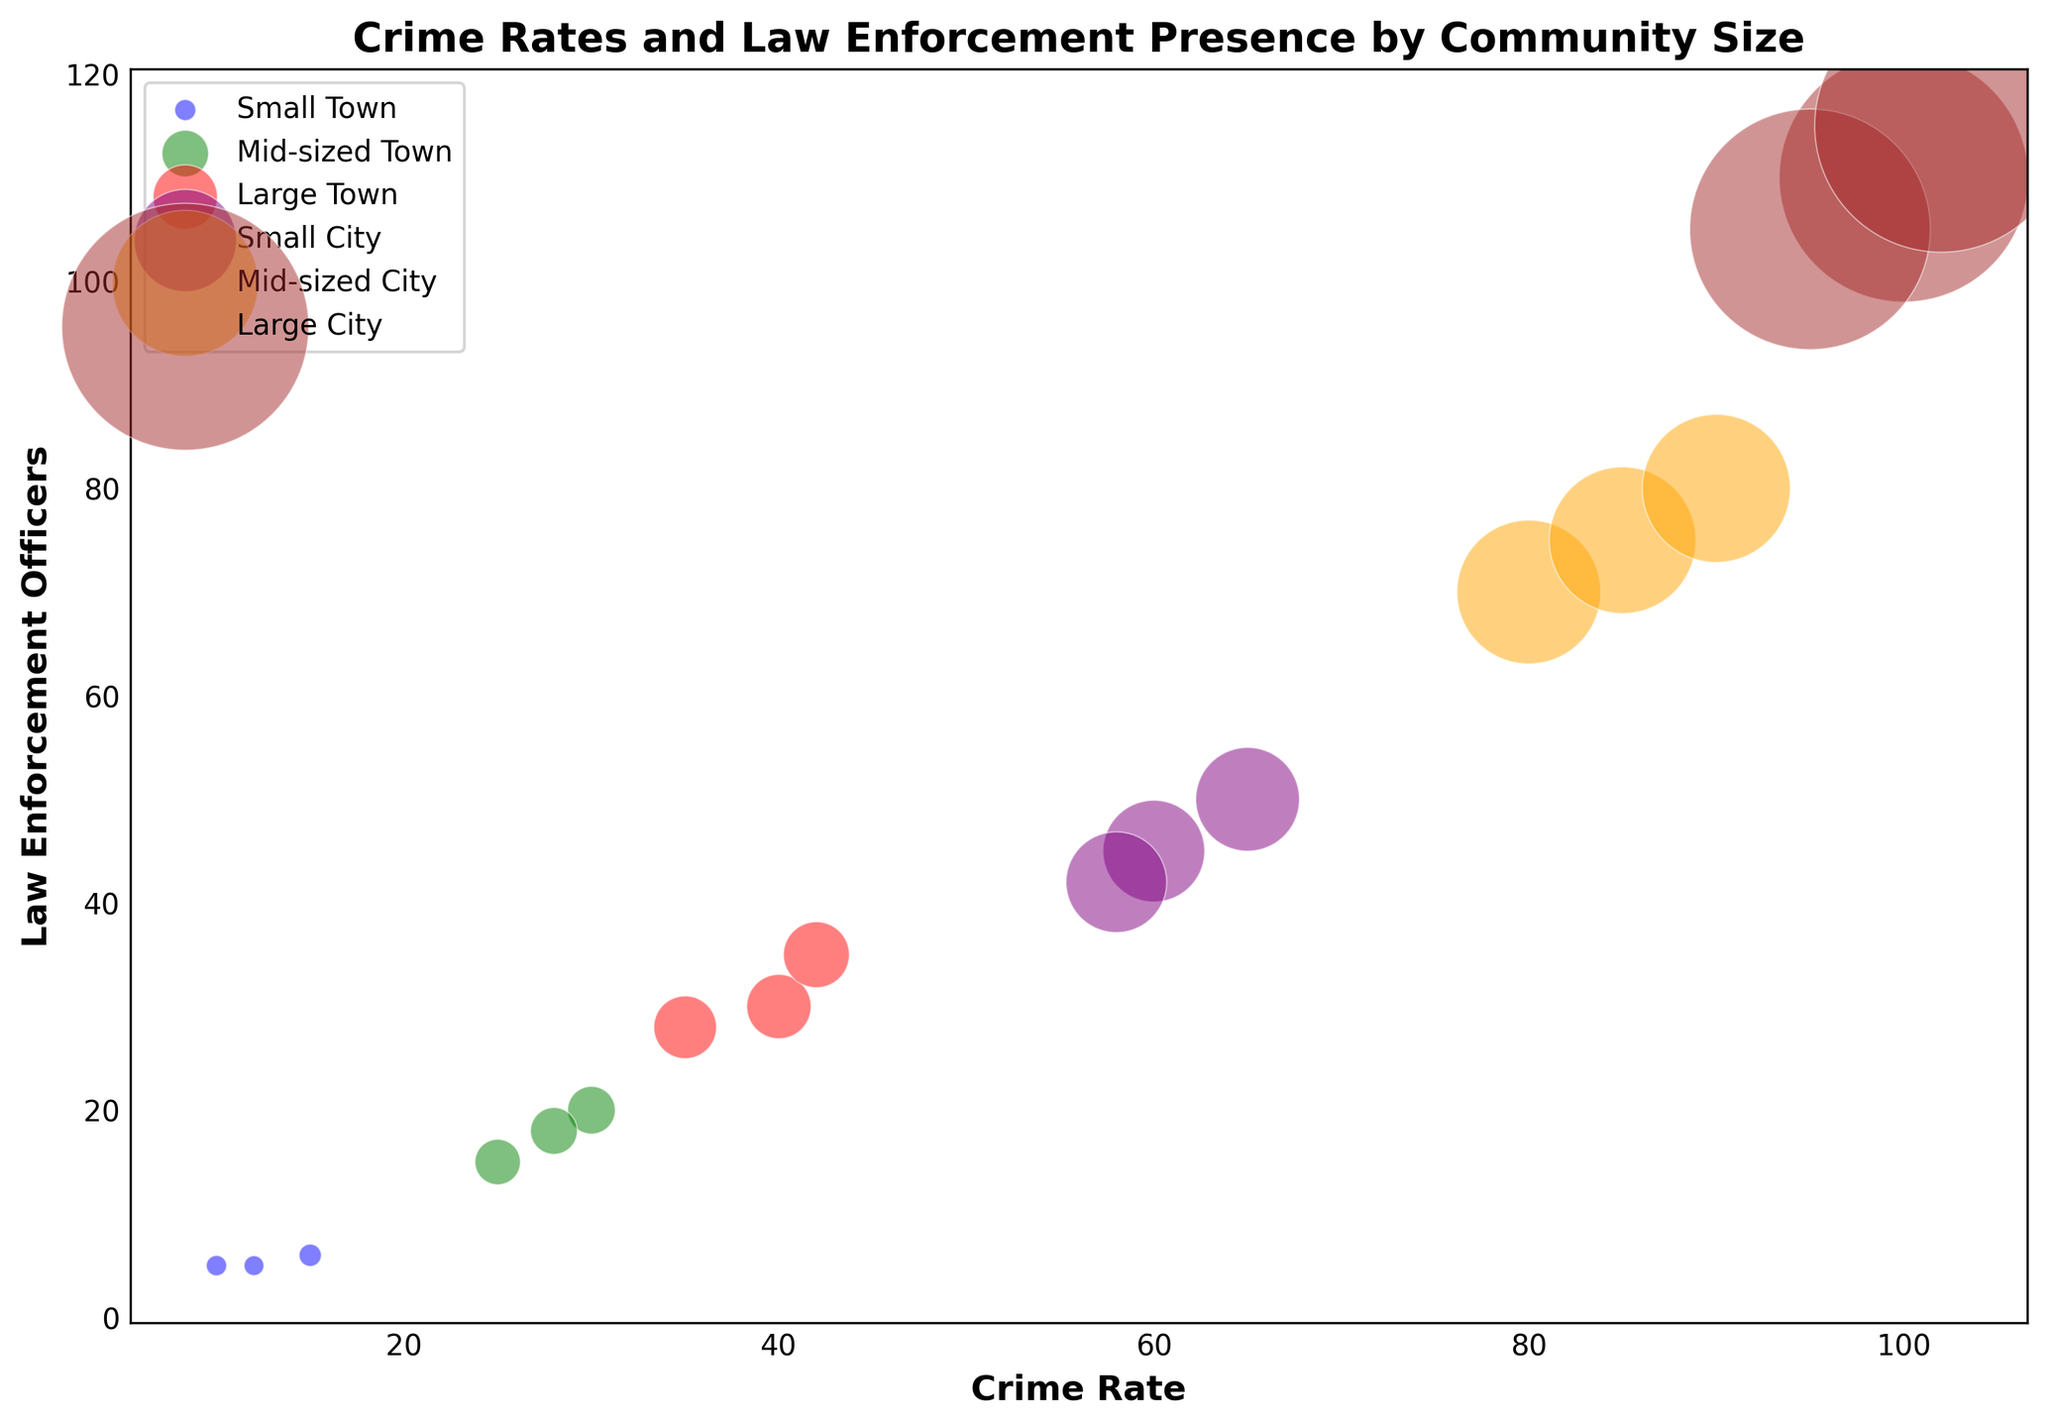What's the distribution of Crime Rate and Law Enforcement Officers across different community sizes? The plot displays various community sizes through different colors with each point representing a community. The points show the relationship between Crime Rate (horizontal axis) and Law Enforcement Officers (vertical axis), indicating how these metrics vary across different community sizes denoted by colors: blue for Small Town, green for Mid-sized Town, red for Large Town, purple for Small City, orange for Mid-sized City, and brown for Large City.
Answer: Crime Rate and Law Enforcement Officers vary by community size, with larger communities generally showing higher rates Which community size has the highest average number of Law Enforcement Officers? By looking at the vertical position of the points, the Large City community size (brown) tends to have the highest values for Law Enforcement Officers.
Answer: Large City Are Crime Rates higher in Small Cities or Large Towns? By comparing the horizontal positions, Small City (purple) points are further to the right than Large Town (red) points, indicating higher Crime Rates.
Answer: Small City Is there a general trend in the size of the bubbles as community size increases? The size of the bubbles represents the population. The bubbles increase in size as the community size increases, as seen from Small Towns to Large Cities.
Answer: Yes What's the sum of Law Enforcement Officers in all Small Town datatypes? The Law Enforcement Officers in Small Towns are 5, 6, and 5. Summing these values gives 5 + 6 + 5 = 16.
Answer: 16 Which color represents the community size with the lowest average Crime Rate? The community size with the lowest average Crime Rate is Small Town, indicated by blue-colored points placed towards the left-most area on the horizontal axis (Crime Rate).
Answer: Blue Between Mid-sized Town and Small City, which has a greater variability in Law Enforcement Officers? Mid-sized Town (green points) has values ranging from 15 to 20, while Small City (purple points) ranges from 42 to 50, showing greater variability.
Answer: Small City Is there any community size that shows overlapping values for Crime Rate and Law Enforcement Officers? No visibly discernible overlap exists among different community sizes when comparing specific pairs of values for Crime Rate and Law Enforcement Officers. Each community size occupies distinct ranges.
Answer: No Do larger populations correlate with higher Crime Rates in the given data? Observing the plot, larger bubbles (representing larger populations) generally tend to be placed towards the right, indicating higher Crime Rates in larger communities.
Answer: Yes How does the average Crime Rate in Mid-sized Cities compare with that in Mid-sized Towns? Mid-sized Cities (orange points) show Crime Rates around 80-90, whereas Mid-sized Towns (green points) show Crime Rates approximately around 25-30. The average Crime Rate is higher in Mid-sized Cities.
Answer: Higher in Mid-sized Cities 